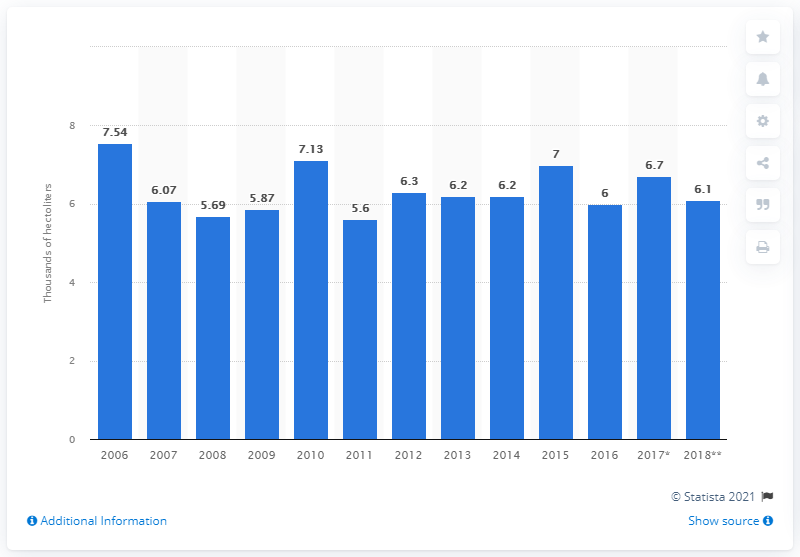Specify some key components in this picture. Portugal's wine production was forecasted to reach 6.1 million liters in 2018. 